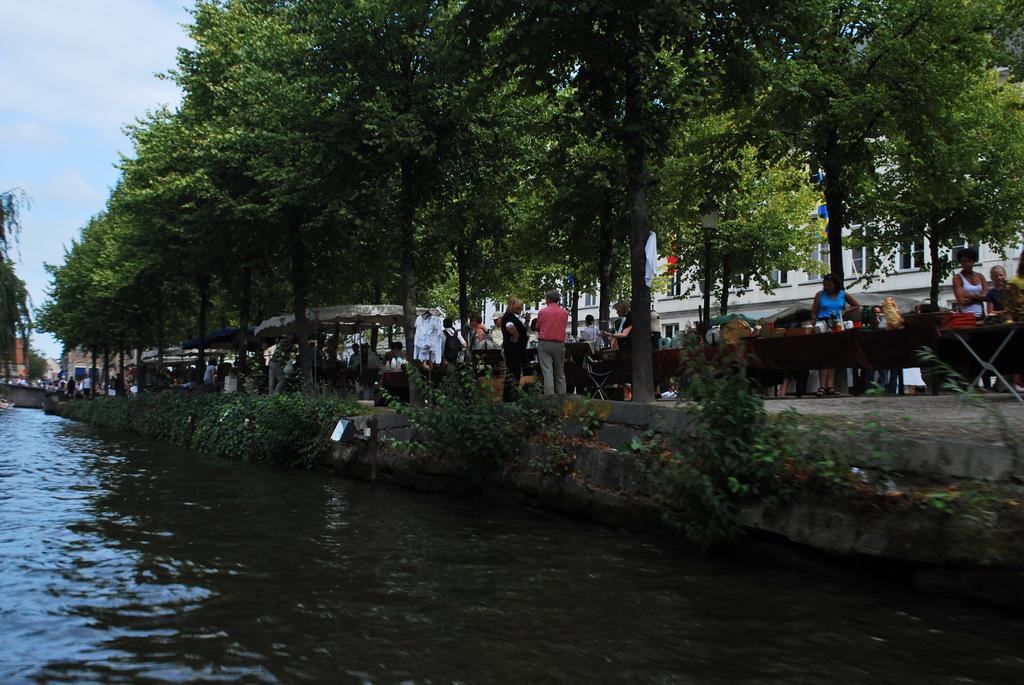Describe this image in one or two sentences. In this picture there is water at the bottom side of the image and there are people and stalls in the center of the image, there are trees and buildings in the background area of the image. 